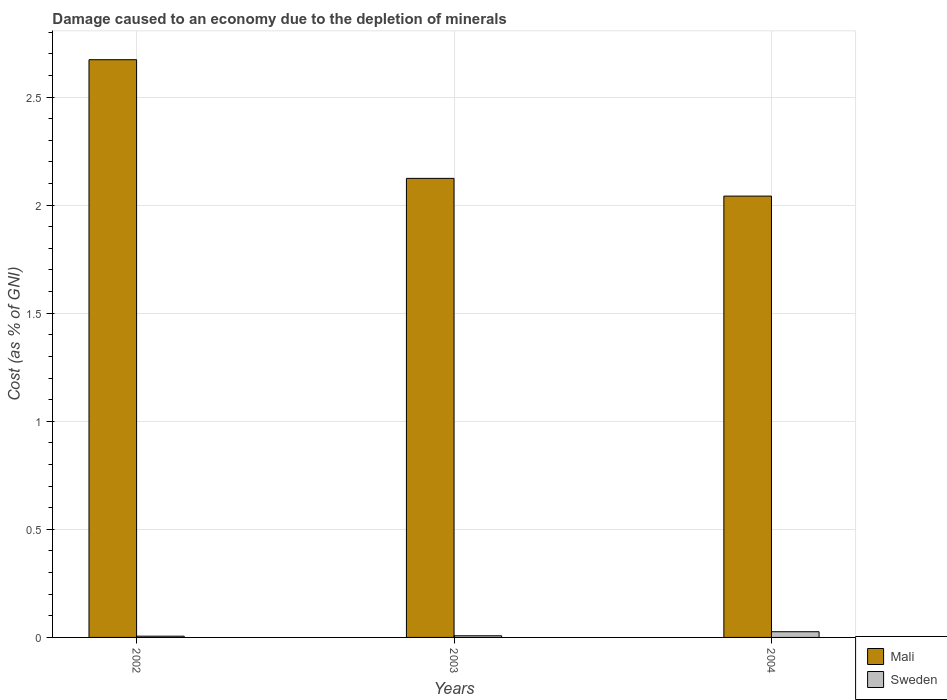How many different coloured bars are there?
Provide a succinct answer. 2. Are the number of bars on each tick of the X-axis equal?
Ensure brevity in your answer.  Yes. How many bars are there on the 3rd tick from the left?
Make the answer very short. 2. How many bars are there on the 2nd tick from the right?
Give a very brief answer. 2. What is the cost of damage caused due to the depletion of minerals in Mali in 2003?
Offer a terse response. 2.12. Across all years, what is the maximum cost of damage caused due to the depletion of minerals in Sweden?
Ensure brevity in your answer.  0.03. Across all years, what is the minimum cost of damage caused due to the depletion of minerals in Mali?
Ensure brevity in your answer.  2.04. In which year was the cost of damage caused due to the depletion of minerals in Mali maximum?
Offer a very short reply. 2002. What is the total cost of damage caused due to the depletion of minerals in Sweden in the graph?
Provide a short and direct response. 0.04. What is the difference between the cost of damage caused due to the depletion of minerals in Sweden in 2002 and that in 2003?
Keep it short and to the point. -0. What is the difference between the cost of damage caused due to the depletion of minerals in Mali in 2003 and the cost of damage caused due to the depletion of minerals in Sweden in 2002?
Your response must be concise. 2.12. What is the average cost of damage caused due to the depletion of minerals in Sweden per year?
Ensure brevity in your answer.  0.01. In the year 2002, what is the difference between the cost of damage caused due to the depletion of minerals in Sweden and cost of damage caused due to the depletion of minerals in Mali?
Give a very brief answer. -2.67. What is the ratio of the cost of damage caused due to the depletion of minerals in Mali in 2002 to that in 2003?
Provide a short and direct response. 1.26. Is the cost of damage caused due to the depletion of minerals in Mali in 2002 less than that in 2004?
Offer a very short reply. No. Is the difference between the cost of damage caused due to the depletion of minerals in Sweden in 2002 and 2003 greater than the difference between the cost of damage caused due to the depletion of minerals in Mali in 2002 and 2003?
Your answer should be very brief. No. What is the difference between the highest and the second highest cost of damage caused due to the depletion of minerals in Sweden?
Provide a succinct answer. 0.02. What is the difference between the highest and the lowest cost of damage caused due to the depletion of minerals in Sweden?
Provide a short and direct response. 0.02. What does the 1st bar from the left in 2004 represents?
Provide a succinct answer. Mali. What does the 1st bar from the right in 2003 represents?
Your answer should be very brief. Sweden. Are all the bars in the graph horizontal?
Offer a very short reply. No. Are the values on the major ticks of Y-axis written in scientific E-notation?
Give a very brief answer. No. Does the graph contain grids?
Offer a terse response. Yes. Where does the legend appear in the graph?
Provide a short and direct response. Bottom right. How many legend labels are there?
Make the answer very short. 2. How are the legend labels stacked?
Provide a short and direct response. Vertical. What is the title of the graph?
Make the answer very short. Damage caused to an economy due to the depletion of minerals. What is the label or title of the Y-axis?
Ensure brevity in your answer.  Cost (as % of GNI). What is the Cost (as % of GNI) in Mali in 2002?
Give a very brief answer. 2.67. What is the Cost (as % of GNI) in Sweden in 2002?
Give a very brief answer. 0.01. What is the Cost (as % of GNI) in Mali in 2003?
Make the answer very short. 2.12. What is the Cost (as % of GNI) of Sweden in 2003?
Make the answer very short. 0.01. What is the Cost (as % of GNI) in Mali in 2004?
Ensure brevity in your answer.  2.04. What is the Cost (as % of GNI) of Sweden in 2004?
Your answer should be compact. 0.03. Across all years, what is the maximum Cost (as % of GNI) in Mali?
Offer a terse response. 2.67. Across all years, what is the maximum Cost (as % of GNI) of Sweden?
Your response must be concise. 0.03. Across all years, what is the minimum Cost (as % of GNI) in Mali?
Keep it short and to the point. 2.04. Across all years, what is the minimum Cost (as % of GNI) in Sweden?
Your response must be concise. 0.01. What is the total Cost (as % of GNI) of Mali in the graph?
Ensure brevity in your answer.  6.84. What is the total Cost (as % of GNI) of Sweden in the graph?
Ensure brevity in your answer.  0.04. What is the difference between the Cost (as % of GNI) of Mali in 2002 and that in 2003?
Ensure brevity in your answer.  0.55. What is the difference between the Cost (as % of GNI) of Sweden in 2002 and that in 2003?
Offer a terse response. -0. What is the difference between the Cost (as % of GNI) of Mali in 2002 and that in 2004?
Your answer should be very brief. 0.63. What is the difference between the Cost (as % of GNI) in Sweden in 2002 and that in 2004?
Keep it short and to the point. -0.02. What is the difference between the Cost (as % of GNI) of Mali in 2003 and that in 2004?
Offer a very short reply. 0.08. What is the difference between the Cost (as % of GNI) in Sweden in 2003 and that in 2004?
Provide a short and direct response. -0.02. What is the difference between the Cost (as % of GNI) of Mali in 2002 and the Cost (as % of GNI) of Sweden in 2003?
Ensure brevity in your answer.  2.66. What is the difference between the Cost (as % of GNI) of Mali in 2002 and the Cost (as % of GNI) of Sweden in 2004?
Provide a short and direct response. 2.65. What is the difference between the Cost (as % of GNI) of Mali in 2003 and the Cost (as % of GNI) of Sweden in 2004?
Make the answer very short. 2.1. What is the average Cost (as % of GNI) of Mali per year?
Your response must be concise. 2.28. What is the average Cost (as % of GNI) of Sweden per year?
Offer a very short reply. 0.01. In the year 2002, what is the difference between the Cost (as % of GNI) of Mali and Cost (as % of GNI) of Sweden?
Ensure brevity in your answer.  2.67. In the year 2003, what is the difference between the Cost (as % of GNI) in Mali and Cost (as % of GNI) in Sweden?
Provide a short and direct response. 2.12. In the year 2004, what is the difference between the Cost (as % of GNI) in Mali and Cost (as % of GNI) in Sweden?
Keep it short and to the point. 2.02. What is the ratio of the Cost (as % of GNI) of Mali in 2002 to that in 2003?
Ensure brevity in your answer.  1.26. What is the ratio of the Cost (as % of GNI) of Sweden in 2002 to that in 2003?
Your answer should be very brief. 0.76. What is the ratio of the Cost (as % of GNI) of Mali in 2002 to that in 2004?
Provide a short and direct response. 1.31. What is the ratio of the Cost (as % of GNI) in Sweden in 2002 to that in 2004?
Offer a very short reply. 0.22. What is the ratio of the Cost (as % of GNI) in Mali in 2003 to that in 2004?
Give a very brief answer. 1.04. What is the ratio of the Cost (as % of GNI) in Sweden in 2003 to that in 2004?
Provide a succinct answer. 0.29. What is the difference between the highest and the second highest Cost (as % of GNI) in Mali?
Give a very brief answer. 0.55. What is the difference between the highest and the second highest Cost (as % of GNI) in Sweden?
Your answer should be very brief. 0.02. What is the difference between the highest and the lowest Cost (as % of GNI) of Mali?
Keep it short and to the point. 0.63. What is the difference between the highest and the lowest Cost (as % of GNI) of Sweden?
Offer a very short reply. 0.02. 